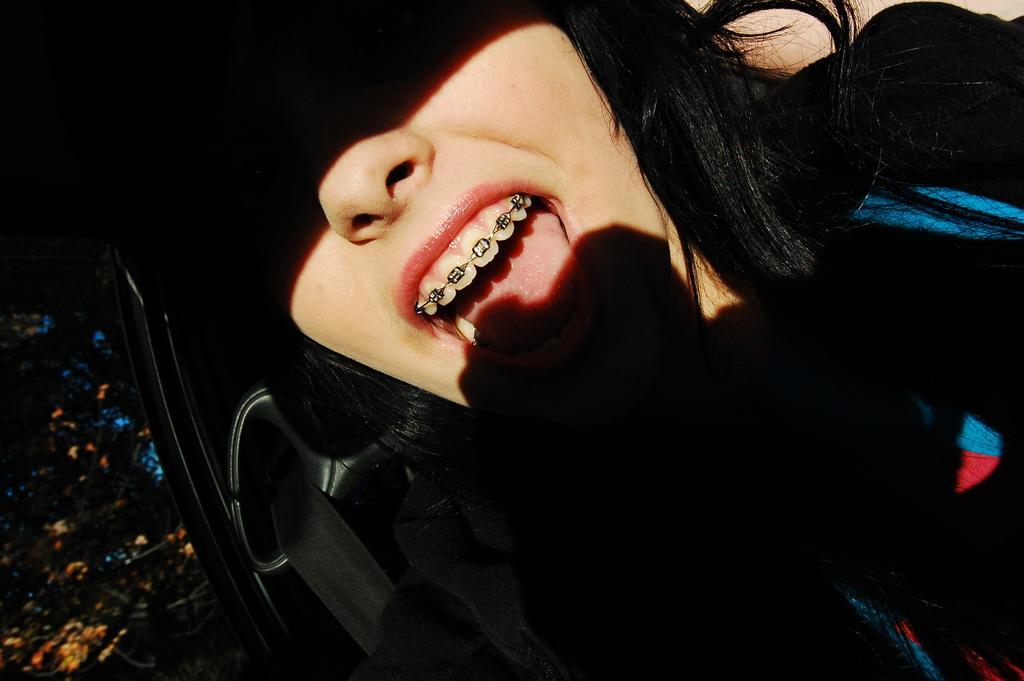Please provide a concise description of this image. In the picture we can see a woman sitting the car wearing a seat belt and she is in a black dress and closing her eyes with the cap and we can only see her mouth which is opened and teeth with clip to it and nose. 